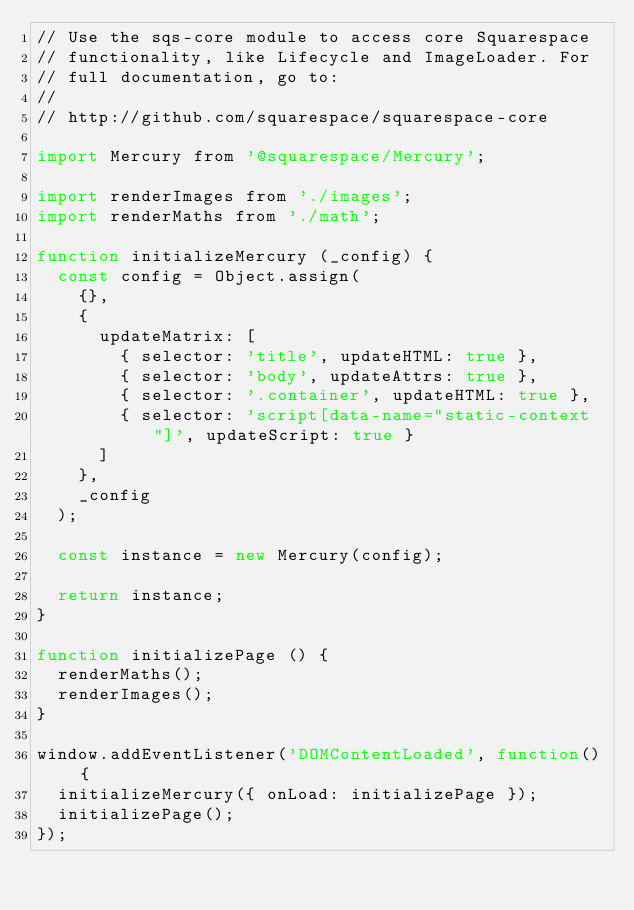<code> <loc_0><loc_0><loc_500><loc_500><_JavaScript_>// Use the sqs-core module to access core Squarespace
// functionality, like Lifecycle and ImageLoader. For
// full documentation, go to:
//
// http://github.com/squarespace/squarespace-core

import Mercury from '@squarespace/Mercury';

import renderImages from './images';
import renderMaths from './math';

function initializeMercury (_config) {
  const config = Object.assign(
    {},
    {
      updateMatrix: [
        { selector: 'title', updateHTML: true },
        { selector: 'body', updateAttrs: true },
        { selector: '.container', updateHTML: true },
        { selector: 'script[data-name="static-context"]', updateScript: true }
      ]
    },
    _config
  );

  const instance = new Mercury(config);

  return instance;
}

function initializePage () {
  renderMaths();
  renderImages();
}

window.addEventListener('DOMContentLoaded', function() {
  initializeMercury({ onLoad: initializePage });
  initializePage();
});
</code> 